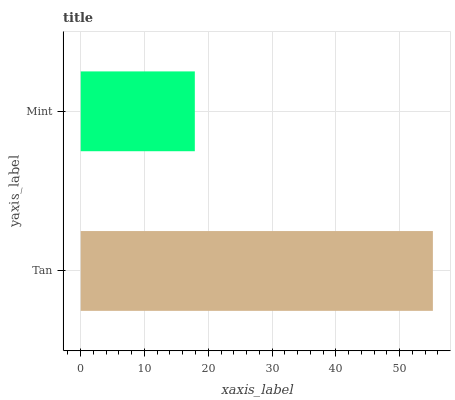Is Mint the minimum?
Answer yes or no. Yes. Is Tan the maximum?
Answer yes or no. Yes. Is Mint the maximum?
Answer yes or no. No. Is Tan greater than Mint?
Answer yes or no. Yes. Is Mint less than Tan?
Answer yes or no. Yes. Is Mint greater than Tan?
Answer yes or no. No. Is Tan less than Mint?
Answer yes or no. No. Is Tan the high median?
Answer yes or no. Yes. Is Mint the low median?
Answer yes or no. Yes. Is Mint the high median?
Answer yes or no. No. Is Tan the low median?
Answer yes or no. No. 